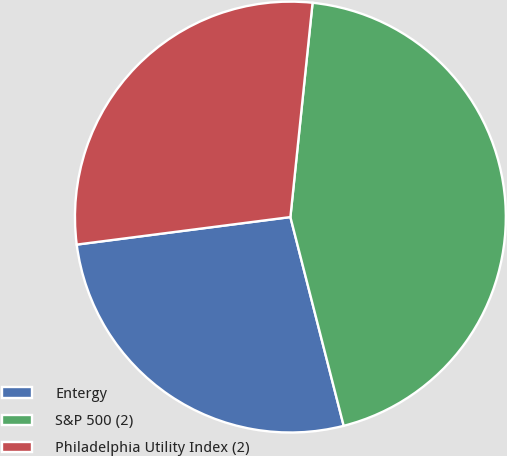Convert chart. <chart><loc_0><loc_0><loc_500><loc_500><pie_chart><fcel>Entergy<fcel>S&P 500 (2)<fcel>Philadelphia Utility Index (2)<nl><fcel>26.94%<fcel>44.38%<fcel>28.68%<nl></chart> 